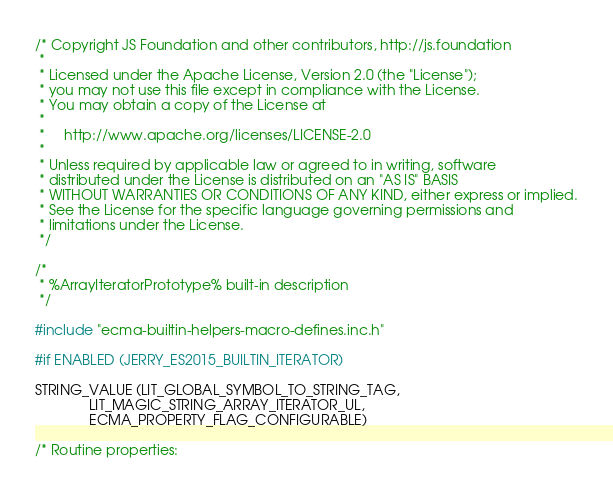<code> <loc_0><loc_0><loc_500><loc_500><_C_>/* Copyright JS Foundation and other contributors, http://js.foundation
 *
 * Licensed under the Apache License, Version 2.0 (the "License");
 * you may not use this file except in compliance with the License.
 * You may obtain a copy of the License at
 *
 *     http://www.apache.org/licenses/LICENSE-2.0
 *
 * Unless required by applicable law or agreed to in writing, software
 * distributed under the License is distributed on an "AS IS" BASIS
 * WITHOUT WARRANTIES OR CONDITIONS OF ANY KIND, either express or implied.
 * See the License for the specific language governing permissions and
 * limitations under the License.
 */

/*
 * %ArrayIteratorPrototype% built-in description
 */

#include "ecma-builtin-helpers-macro-defines.inc.h"

#if ENABLED (JERRY_ES2015_BUILTIN_ITERATOR)

STRING_VALUE (LIT_GLOBAL_SYMBOL_TO_STRING_TAG,
              LIT_MAGIC_STRING_ARRAY_ITERATOR_UL,
              ECMA_PROPERTY_FLAG_CONFIGURABLE)

/* Routine properties:</code> 